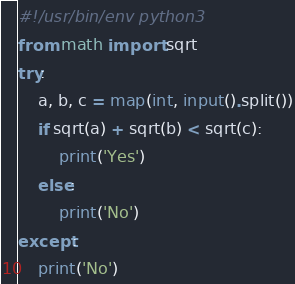Convert code to text. <code><loc_0><loc_0><loc_500><loc_500><_Python_>#!/usr/bin/env python3
from math import sqrt
try:
    a, b, c = map(int, input().split())
    if sqrt(a) + sqrt(b) < sqrt(c):
        print('Yes')
    else:
        print('No')
except:
    print('No')</code> 